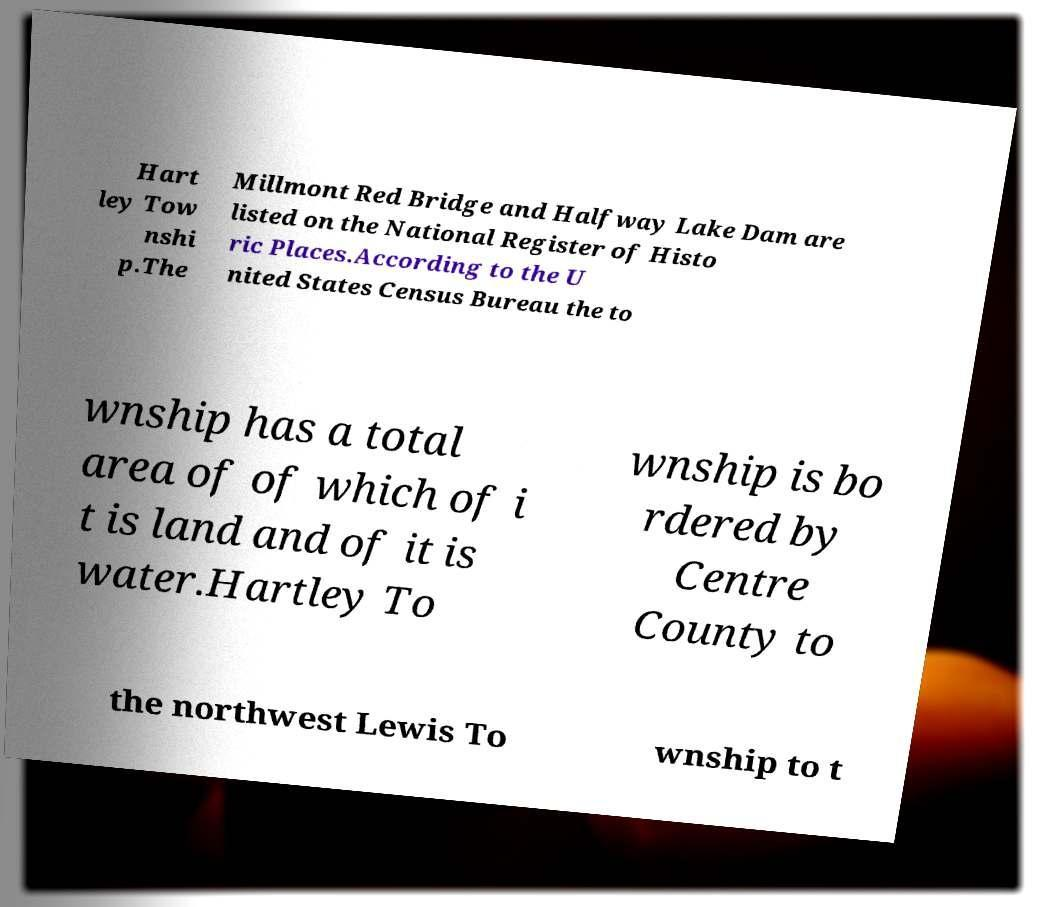Could you extract and type out the text from this image? Hart ley Tow nshi p.The Millmont Red Bridge and Halfway Lake Dam are listed on the National Register of Histo ric Places.According to the U nited States Census Bureau the to wnship has a total area of of which of i t is land and of it is water.Hartley To wnship is bo rdered by Centre County to the northwest Lewis To wnship to t 